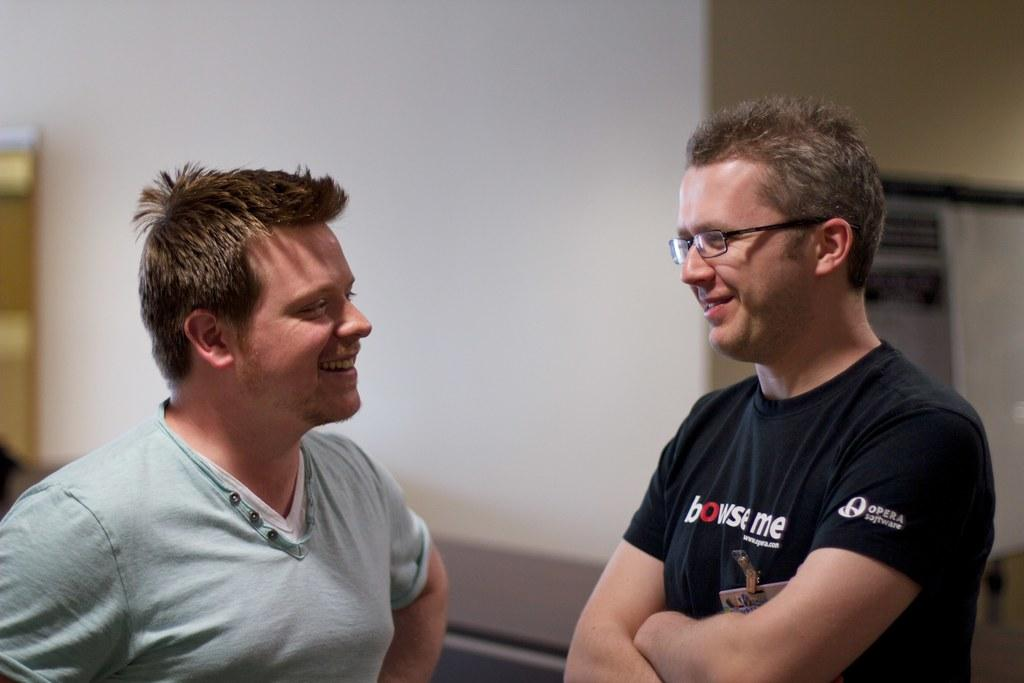How many people are in the image? There are two men in the image. What expression do the men have in the image? The men are smiling in the image. What can be seen in the background of the image? There is a wall in the background of the image. What type of paste is being used by the men in the image? There is no paste present in the image; the men are simply smiling. 